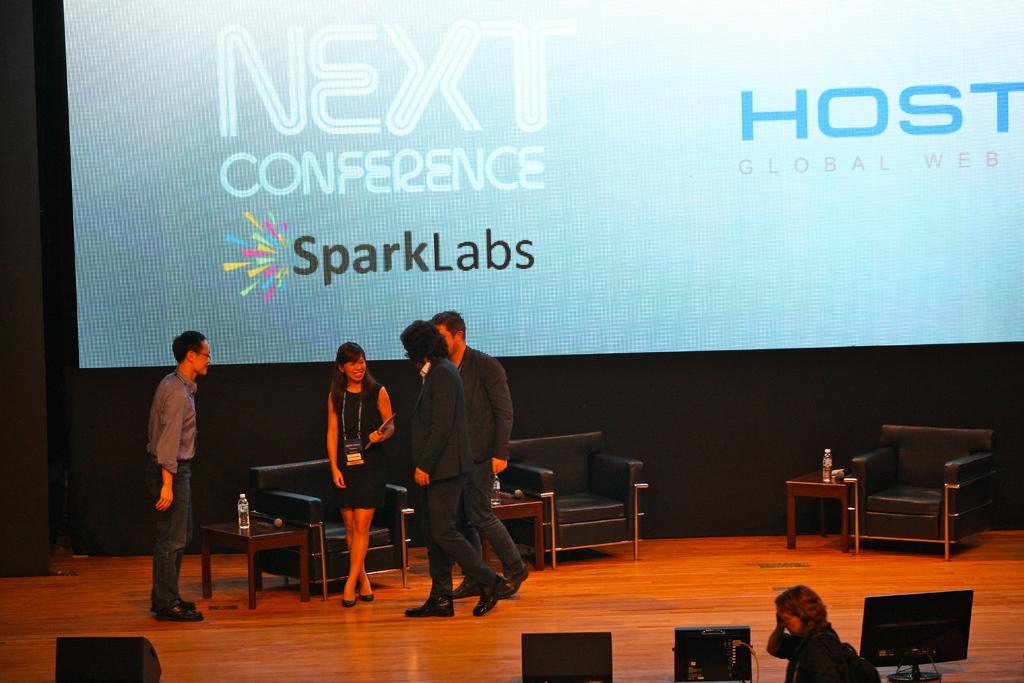Describe this image in one or two sentences. There are four people standing on a stage. There is a table. There is bottle on a table. We can see in the background there is a poster. 